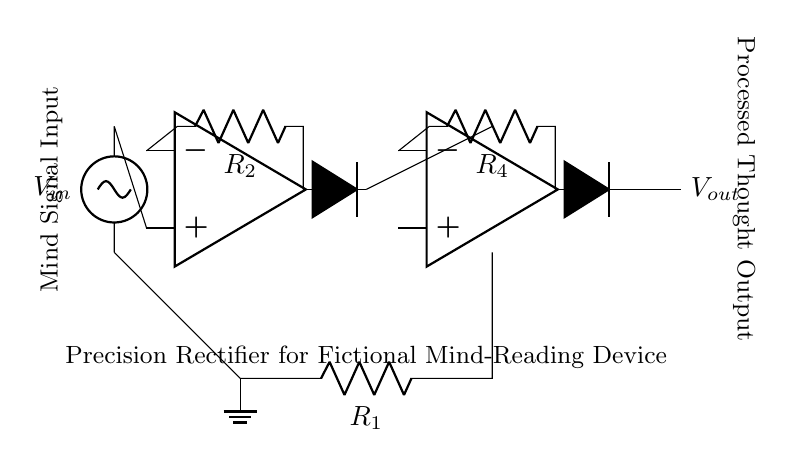What is the input voltage in this circuit? The input voltage, denoted as V_in, is represented by the voltage source on the left side of the circuit diagram.
Answer: V_in What do the diodes in this circuit do? The diodes function as rectifying elements in the circuit. They allow current to flow in one direction while blocking it in the opposite direction, effectively converting an alternating signal from the mind signal input into a unidirectional output.
Answer: Rectification How many operational amplifiers are present? By counting the symbols designated as op amps in the diagram, we find two distinct operational amplifiers involved in processing the signals.
Answer: 2 What is the purpose of resistor R_1? Resistor R_1 is used to set the gain of the first operational amplifier stage, which helps in amplifying the incoming mind signal before it passes through the rectifying diodes.
Answer: Gain setting What is the function of the output voltage V_out? V_out represents the processed thought output from the circuit, indicating that after the input is amplified by the operational amplifiers and rectified by the diodes, it is output as a usable signal representing the detected mind signal.
Answer: Processed thought output How does the feedback connection impact this precision rectifier? The feedback connection from the output of the operational amplifier back to its inverting terminal allows for the precision enhancement of the rectification process, ensuring higher accuracy in tracking small signals, which is crucial for mind-reading capabilities.
Answer: Enhances precision What distinguishes a precision rectifier from a standard rectifier? A precision rectifier, like the one shown in the circuit, uses operational amplifiers to minimize the voltage drop normally seen in standard diodes, allowing even small input signals to be accurately rectified, which is vital for this mind-reading application.
Answer: Voltage drop reduction 